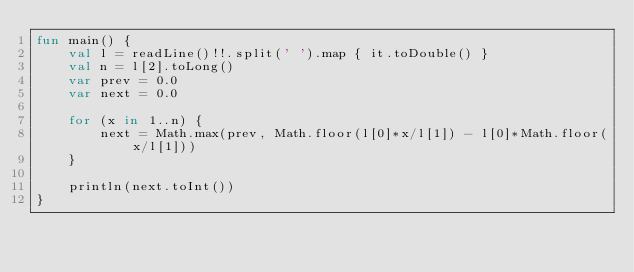<code> <loc_0><loc_0><loc_500><loc_500><_Kotlin_>fun main() {
    val l = readLine()!!.split(' ').map { it.toDouble() }
    val n = l[2].toLong()
    var prev = 0.0
    var next = 0.0

    for (x in 1..n) {
        next = Math.max(prev, Math.floor(l[0]*x/l[1]) - l[0]*Math.floor(x/l[1]))
    }

    println(next.toInt())
}

</code> 